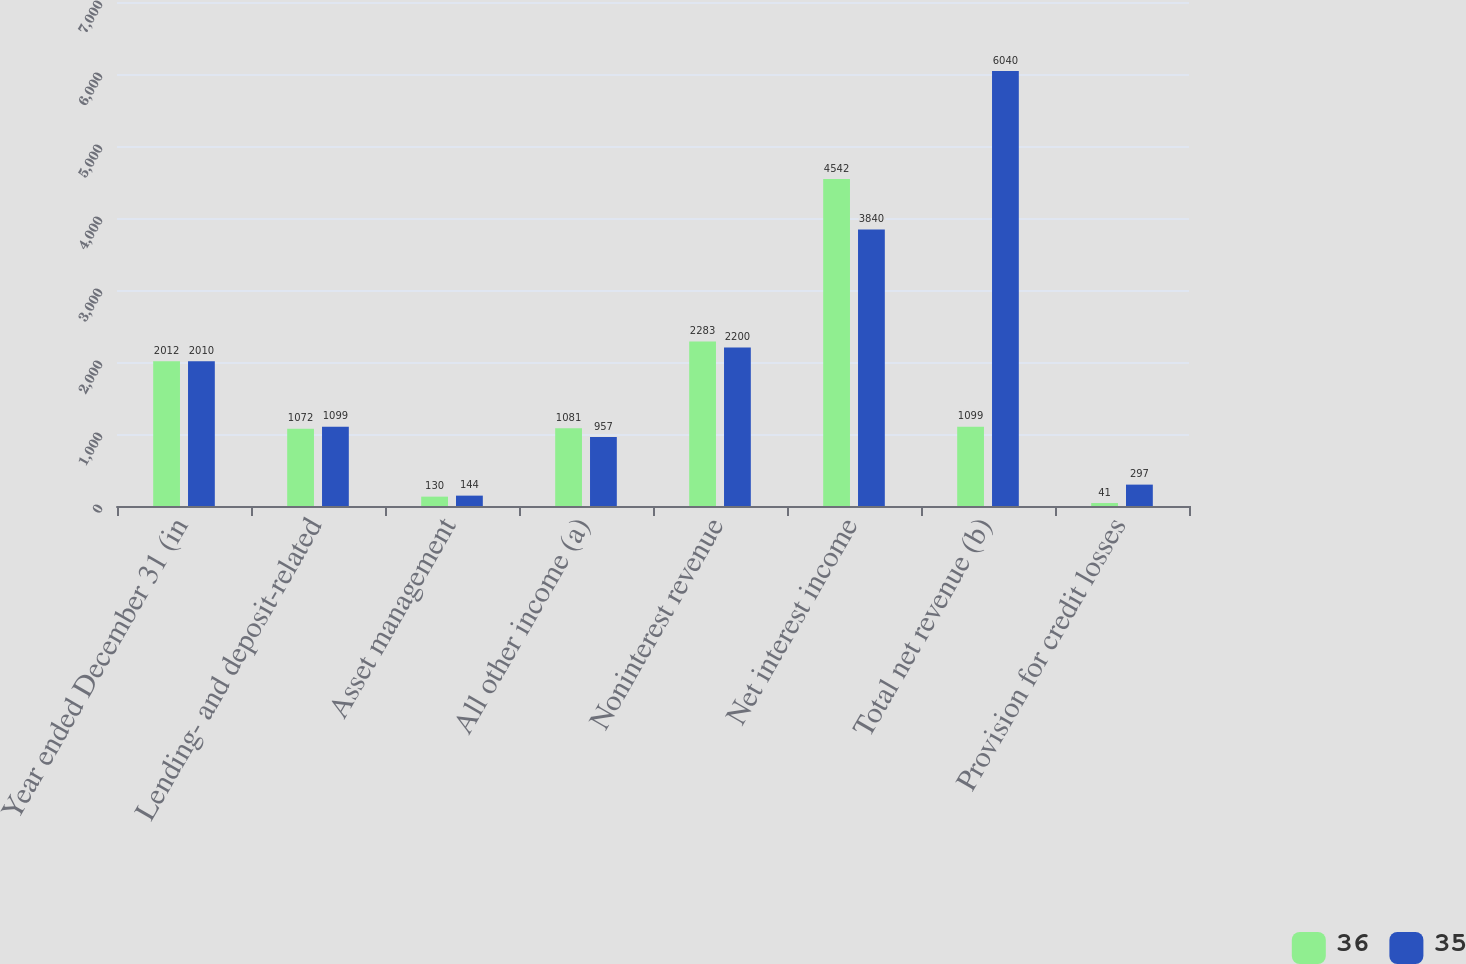Convert chart. <chart><loc_0><loc_0><loc_500><loc_500><stacked_bar_chart><ecel><fcel>Year ended December 31 (in<fcel>Lending- and deposit-related<fcel>Asset management<fcel>All other income (a)<fcel>Noninterest revenue<fcel>Net interest income<fcel>Total net revenue (b)<fcel>Provision for credit losses<nl><fcel>36<fcel>2012<fcel>1072<fcel>130<fcel>1081<fcel>2283<fcel>4542<fcel>1099<fcel>41<nl><fcel>35<fcel>2010<fcel>1099<fcel>144<fcel>957<fcel>2200<fcel>3840<fcel>6040<fcel>297<nl></chart> 